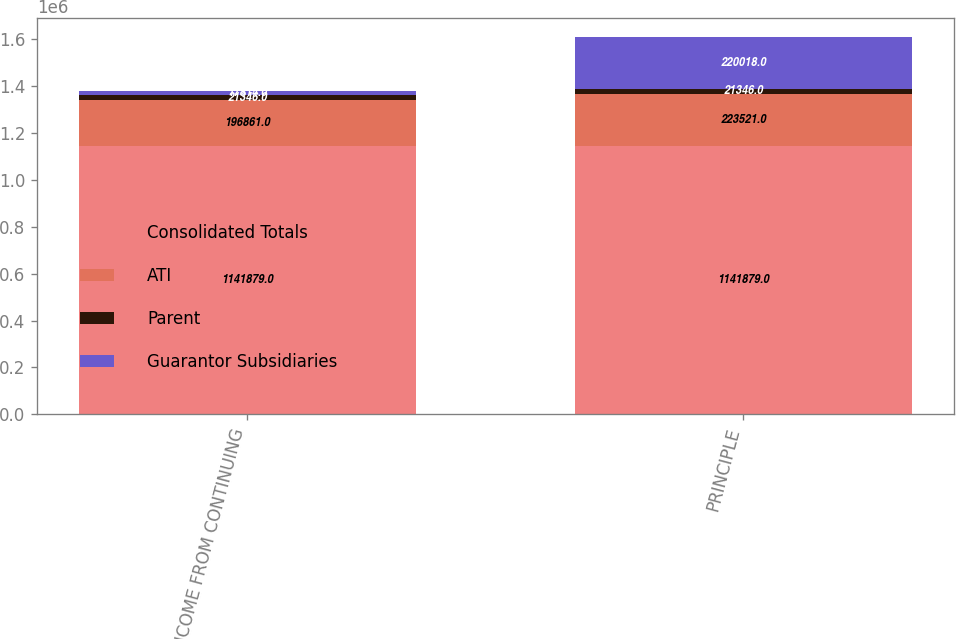Convert chart. <chart><loc_0><loc_0><loc_500><loc_500><stacked_bar_chart><ecel><fcel>(LOSS) INCOME FROM CONTINUING<fcel>PRINCIPLE<nl><fcel>Consolidated Totals<fcel>1.14188e+06<fcel>1.14188e+06<nl><fcel>ATI<fcel>196861<fcel>223521<nl><fcel>Parent<fcel>21346<fcel>21346<nl><fcel>Guarantor Subsidiaries<fcel>17814<fcel>220018<nl></chart> 